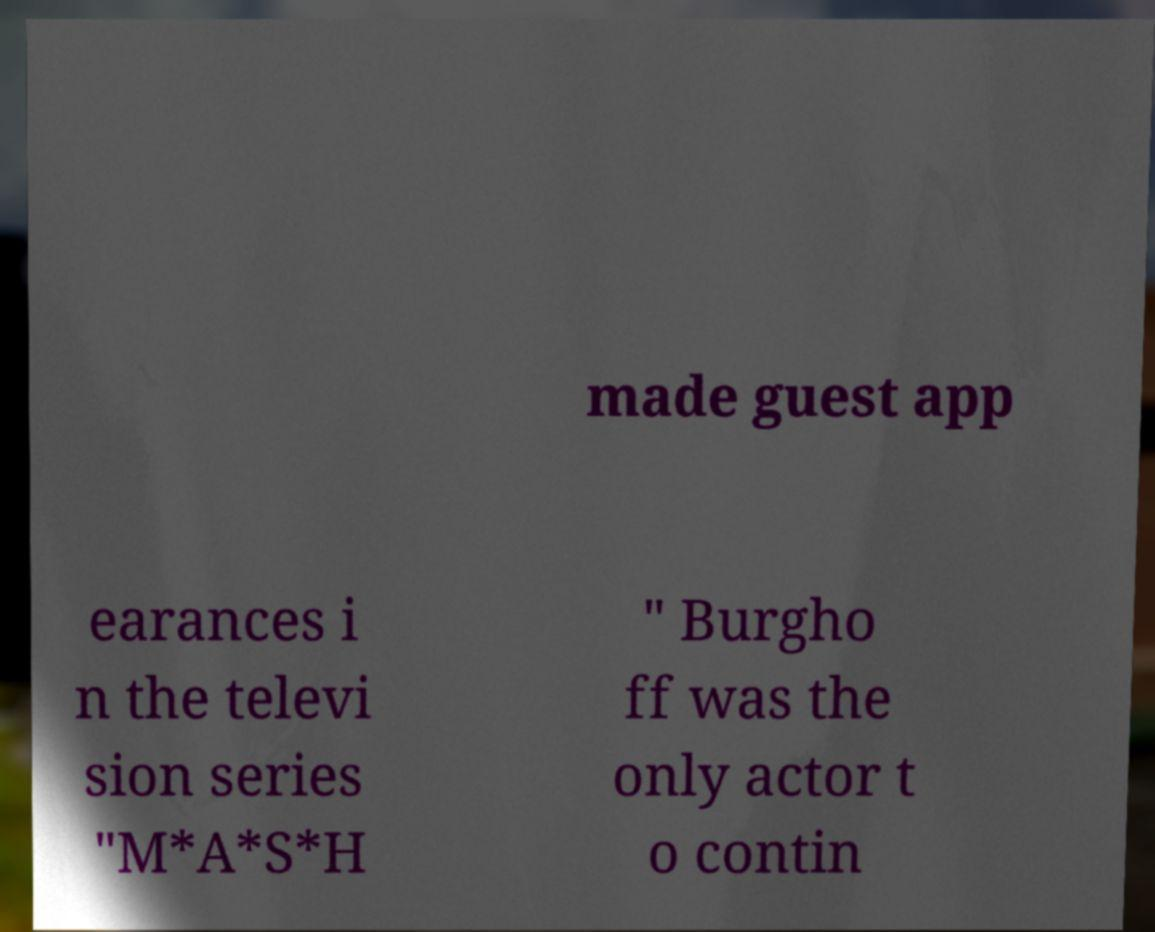Could you assist in decoding the text presented in this image and type it out clearly? made guest app earances i n the televi sion series "M*A*S*H " Burgho ff was the only actor t o contin 